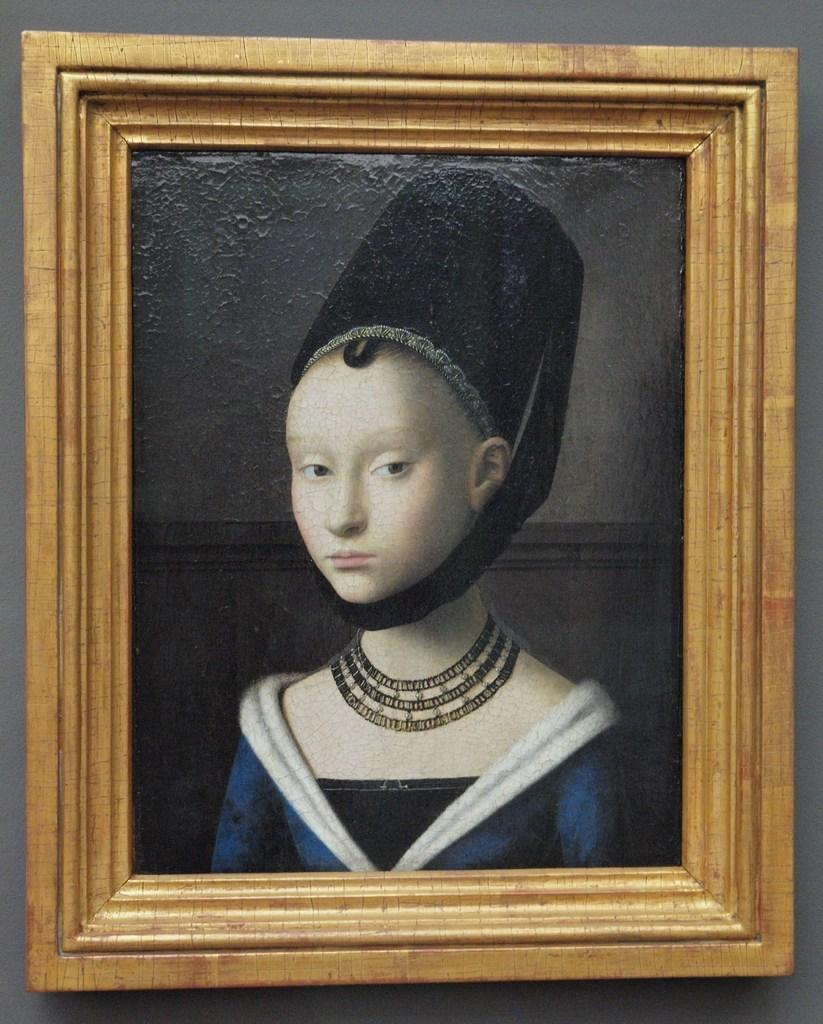What is the main feature in the foreground of the image? There is a grey color wall-like structure in the foreground. Can you describe the color and texture of the wall-like structure? The wall-like structure is grey in color and has a solid, flat appearance. Is there anything else visible in the image besides the wall-like structure? The provided facts do not mention any other objects or features in the image. What type of cake is being served at the time depicted in the image? There is no cake or time reference present in the image; it only features a grey color wall-like structure in the foreground. 